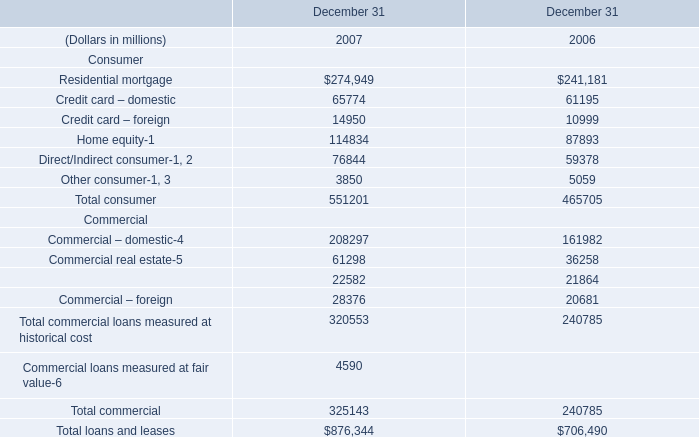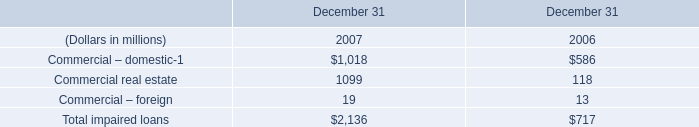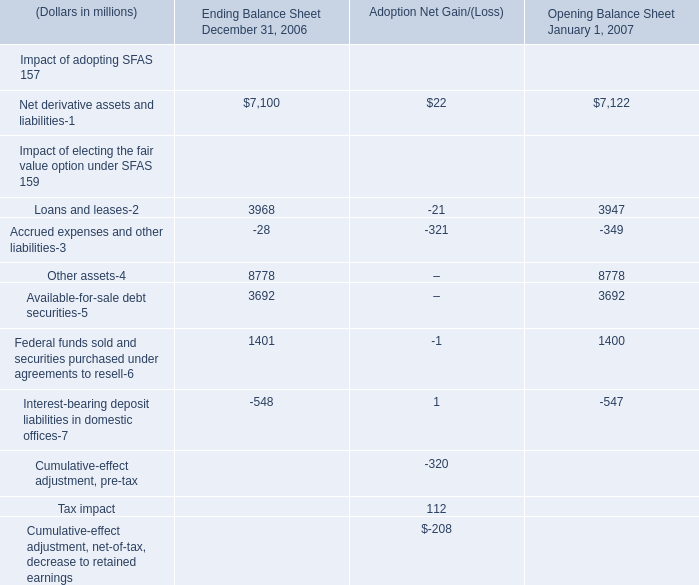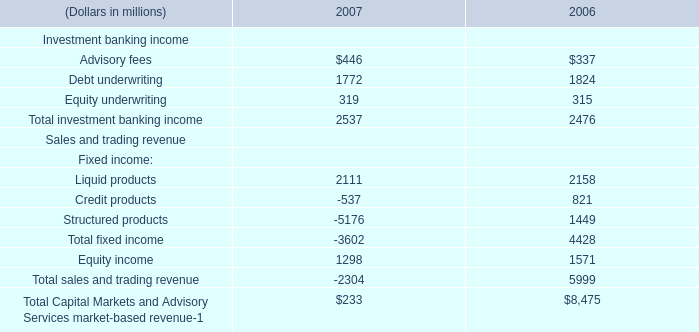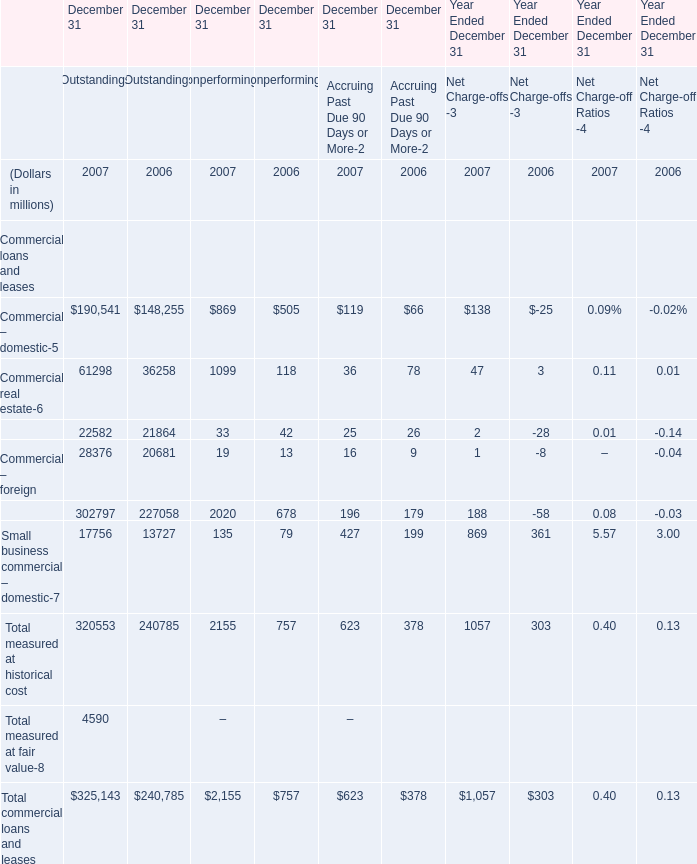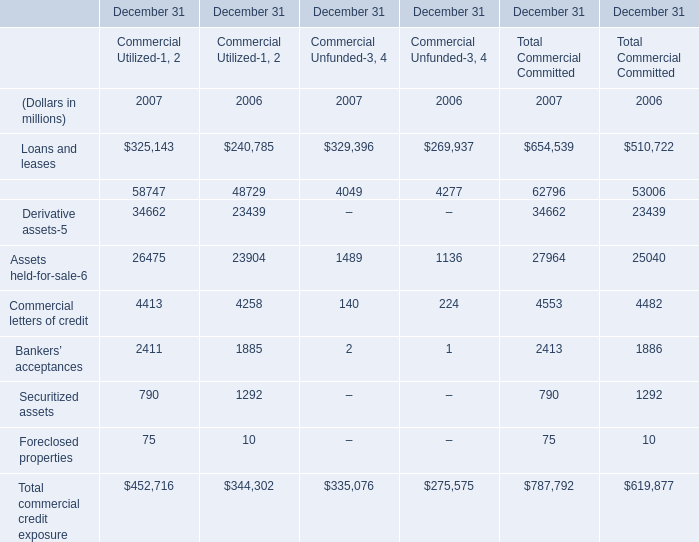What was the average value of Commercial – domestic, Commercial real estate, Commercial lease financing in 2007 for Outstandings? (in million) 
Computations: ((190541 + 61298) + 22582)
Answer: 274421.0. 